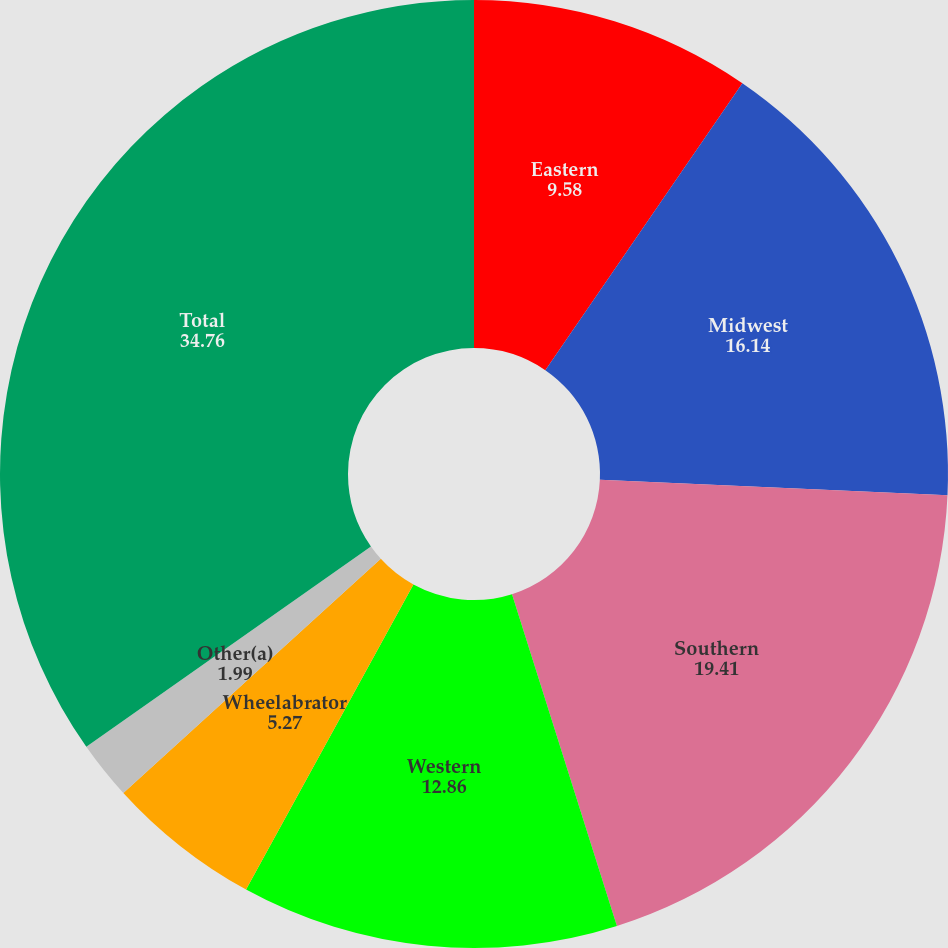<chart> <loc_0><loc_0><loc_500><loc_500><pie_chart><fcel>Eastern<fcel>Midwest<fcel>Southern<fcel>Western<fcel>Wheelabrator<fcel>Other(a)<fcel>Total<nl><fcel>9.58%<fcel>16.14%<fcel>19.41%<fcel>12.86%<fcel>5.27%<fcel>1.99%<fcel>34.76%<nl></chart> 